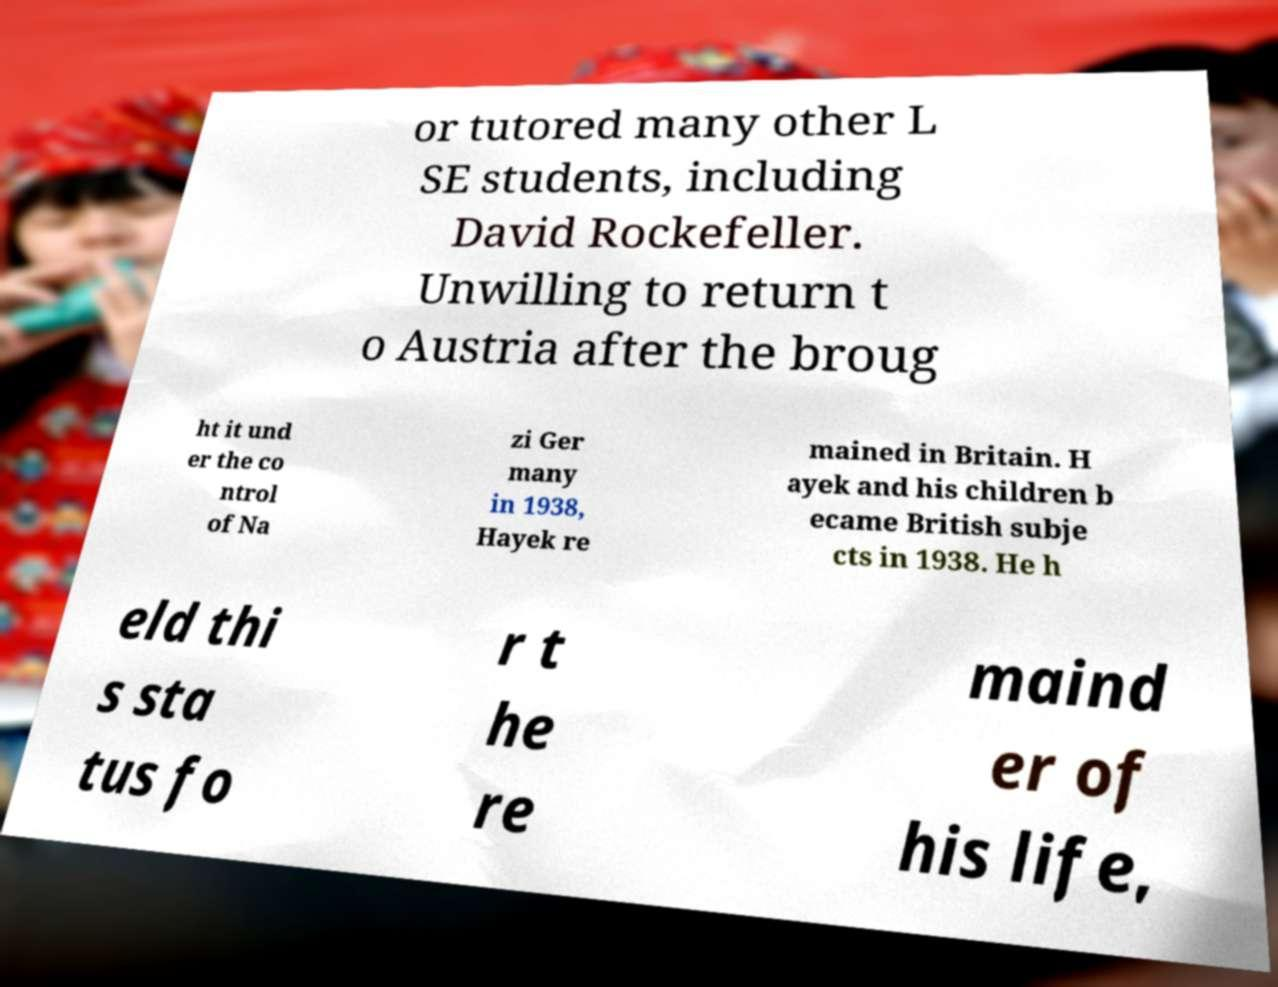I need the written content from this picture converted into text. Can you do that? or tutored many other L SE students, including David Rockefeller. Unwilling to return t o Austria after the broug ht it und er the co ntrol of Na zi Ger many in 1938, Hayek re mained in Britain. H ayek and his children b ecame British subje cts in 1938. He h eld thi s sta tus fo r t he re maind er of his life, 